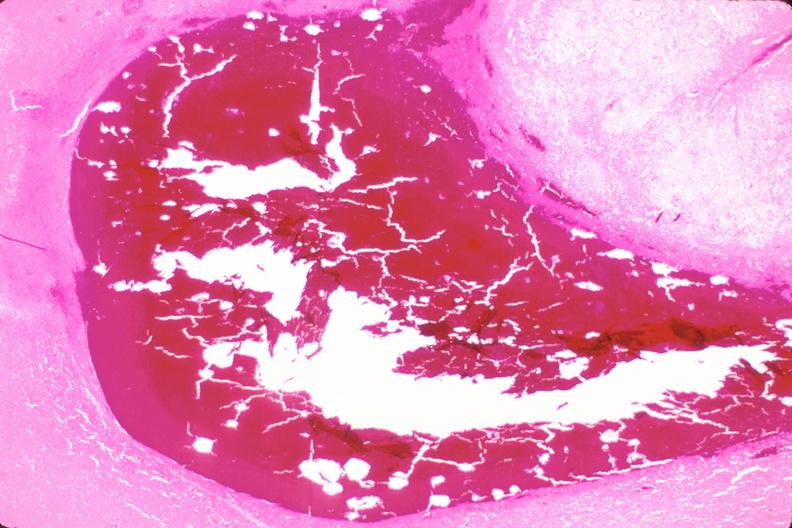does this image show brain, subarachanoid hemorrhage and hematoma due to ruptured aneurysm?
Answer the question using a single word or phrase. Yes 